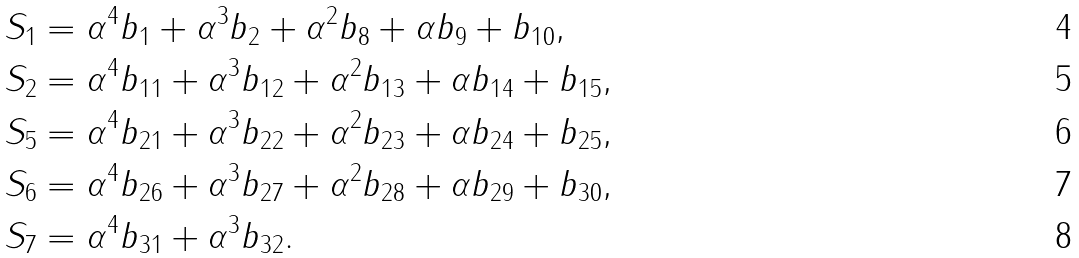<formula> <loc_0><loc_0><loc_500><loc_500>S _ { 1 } & = \alpha ^ { 4 } b _ { 1 } + \alpha ^ { 3 } b _ { 2 } + \alpha ^ { 2 } b _ { 8 } + \alpha b _ { 9 } + b _ { 1 0 } , \\ S _ { 2 } & = \alpha ^ { 4 } b _ { 1 1 } + \alpha ^ { 3 } b _ { 1 2 } + \alpha ^ { 2 } b _ { 1 3 } + \alpha b _ { 1 4 } + b _ { 1 5 } , \\ S _ { 5 } & = \alpha ^ { 4 } b _ { 2 1 } + \alpha ^ { 3 } b _ { 2 2 } + \alpha ^ { 2 } b _ { 2 3 } + \alpha b _ { 2 4 } + b _ { 2 5 } , \\ S _ { 6 } & = \alpha ^ { 4 } b _ { 2 6 } + \alpha ^ { 3 } b _ { 2 7 } + \alpha ^ { 2 } b _ { 2 8 } + \alpha b _ { 2 9 } + b _ { 3 0 } , \\ S _ { 7 } & = \alpha ^ { 4 } b _ { 3 1 } + \alpha ^ { 3 } b _ { 3 2 } .</formula> 